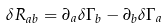<formula> <loc_0><loc_0><loc_500><loc_500>\delta R _ { a b } = \partial _ { a } \delta \Gamma _ { b } - \partial _ { b } \delta \Gamma _ { a }</formula> 